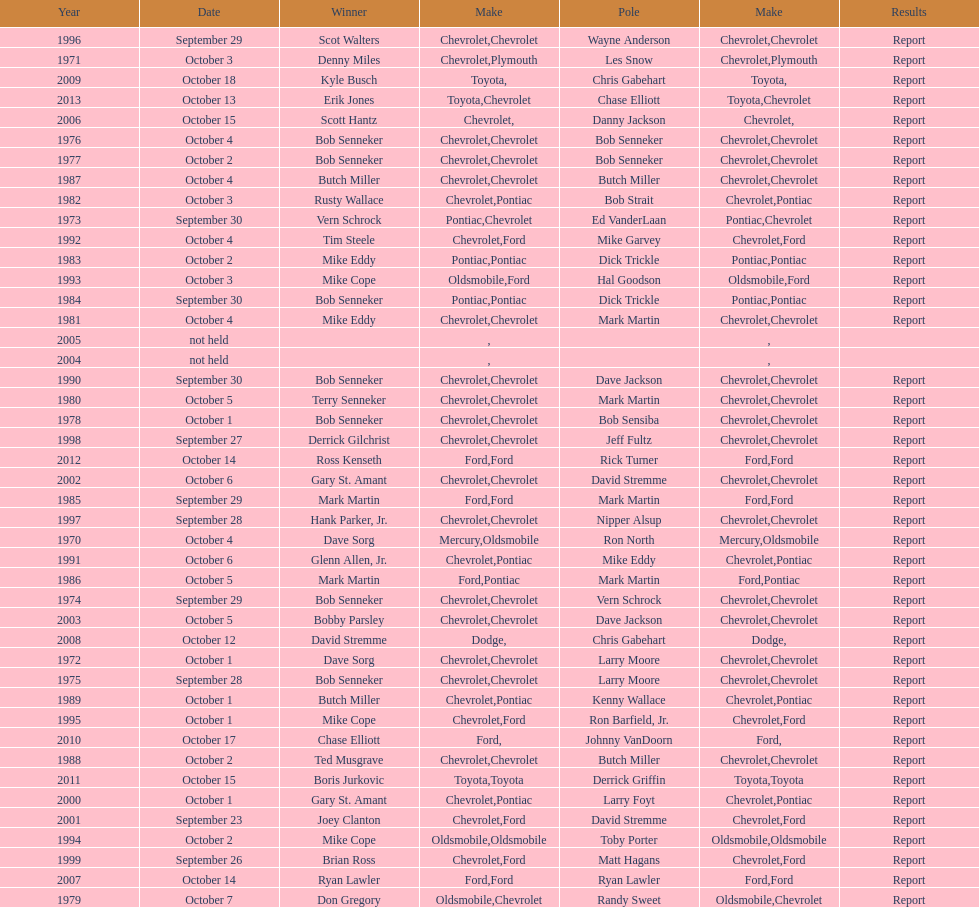Would you be able to parse every entry in this table? {'header': ['Year', 'Date', 'Winner', 'Make', 'Pole', 'Make', 'Results'], 'rows': [['1996', 'September 29', 'Scot Walters', 'Chevrolet', 'Wayne Anderson', 'Chevrolet', 'Report'], ['1971', 'October 3', 'Denny Miles', 'Chevrolet', 'Les Snow', 'Plymouth', 'Report'], ['2009', 'October 18', 'Kyle Busch', 'Toyota', 'Chris Gabehart', '', 'Report'], ['2013', 'October 13', 'Erik Jones', 'Toyota', 'Chase Elliott', 'Chevrolet', 'Report'], ['2006', 'October 15', 'Scott Hantz', 'Chevrolet', 'Danny Jackson', '', 'Report'], ['1976', 'October 4', 'Bob Senneker', 'Chevrolet', 'Bob Senneker', 'Chevrolet', 'Report'], ['1977', 'October 2', 'Bob Senneker', 'Chevrolet', 'Bob Senneker', 'Chevrolet', 'Report'], ['1987', 'October 4', 'Butch Miller', 'Chevrolet', 'Butch Miller', 'Chevrolet', 'Report'], ['1982', 'October 3', 'Rusty Wallace', 'Chevrolet', 'Bob Strait', 'Pontiac', 'Report'], ['1973', 'September 30', 'Vern Schrock', 'Pontiac', 'Ed VanderLaan', 'Chevrolet', 'Report'], ['1992', 'October 4', 'Tim Steele', 'Chevrolet', 'Mike Garvey', 'Ford', 'Report'], ['1983', 'October 2', 'Mike Eddy', 'Pontiac', 'Dick Trickle', 'Pontiac', 'Report'], ['1993', 'October 3', 'Mike Cope', 'Oldsmobile', 'Hal Goodson', 'Ford', 'Report'], ['1984', 'September 30', 'Bob Senneker', 'Pontiac', 'Dick Trickle', 'Pontiac', 'Report'], ['1981', 'October 4', 'Mike Eddy', 'Chevrolet', 'Mark Martin', 'Chevrolet', 'Report'], ['2005', 'not held', '', '', '', '', ''], ['2004', 'not held', '', '', '', '', ''], ['1990', 'September 30', 'Bob Senneker', 'Chevrolet', 'Dave Jackson', 'Chevrolet', 'Report'], ['1980', 'October 5', 'Terry Senneker', 'Chevrolet', 'Mark Martin', 'Chevrolet', 'Report'], ['1978', 'October 1', 'Bob Senneker', 'Chevrolet', 'Bob Sensiba', 'Chevrolet', 'Report'], ['1998', 'September 27', 'Derrick Gilchrist', 'Chevrolet', 'Jeff Fultz', 'Chevrolet', 'Report'], ['2012', 'October 14', 'Ross Kenseth', 'Ford', 'Rick Turner', 'Ford', 'Report'], ['2002', 'October 6', 'Gary St. Amant', 'Chevrolet', 'David Stremme', 'Chevrolet', 'Report'], ['1985', 'September 29', 'Mark Martin', 'Ford', 'Mark Martin', 'Ford', 'Report'], ['1997', 'September 28', 'Hank Parker, Jr.', 'Chevrolet', 'Nipper Alsup', 'Chevrolet', 'Report'], ['1970', 'October 4', 'Dave Sorg', 'Mercury', 'Ron North', 'Oldsmobile', 'Report'], ['1991', 'October 6', 'Glenn Allen, Jr.', 'Chevrolet', 'Mike Eddy', 'Pontiac', 'Report'], ['1986', 'October 5', 'Mark Martin', 'Ford', 'Mark Martin', 'Pontiac', 'Report'], ['1974', 'September 29', 'Bob Senneker', 'Chevrolet', 'Vern Schrock', 'Chevrolet', 'Report'], ['2003', 'October 5', 'Bobby Parsley', 'Chevrolet', 'Dave Jackson', 'Chevrolet', 'Report'], ['2008', 'October 12', 'David Stremme', 'Dodge', 'Chris Gabehart', '', 'Report'], ['1972', 'October 1', 'Dave Sorg', 'Chevrolet', 'Larry Moore', 'Chevrolet', 'Report'], ['1975', 'September 28', 'Bob Senneker', 'Chevrolet', 'Larry Moore', 'Chevrolet', 'Report'], ['1989', 'October 1', 'Butch Miller', 'Chevrolet', 'Kenny Wallace', 'Pontiac', 'Report'], ['1995', 'October 1', 'Mike Cope', 'Chevrolet', 'Ron Barfield, Jr.', 'Ford', 'Report'], ['2010', 'October 17', 'Chase Elliott', 'Ford', 'Johnny VanDoorn', '', 'Report'], ['1988', 'October 2', 'Ted Musgrave', 'Chevrolet', 'Butch Miller', 'Chevrolet', 'Report'], ['2011', 'October 15', 'Boris Jurkovic', 'Toyota', 'Derrick Griffin', 'Toyota', 'Report'], ['2000', 'October 1', 'Gary St. Amant', 'Chevrolet', 'Larry Foyt', 'Pontiac', 'Report'], ['2001', 'September 23', 'Joey Clanton', 'Chevrolet', 'David Stremme', 'Ford', 'Report'], ['1994', 'October 2', 'Mike Cope', 'Oldsmobile', 'Toby Porter', 'Oldsmobile', 'Report'], ['1999', 'September 26', 'Brian Ross', 'Chevrolet', 'Matt Hagans', 'Ford', 'Report'], ['2007', 'October 14', 'Ryan Lawler', 'Ford', 'Ryan Lawler', 'Ford', 'Report'], ['1979', 'October 7', 'Don Gregory', 'Oldsmobile', 'Randy Sweet', 'Chevrolet', 'Report']]} Who holds the record for the most consecutive victories on the list? Bob Senneker. 